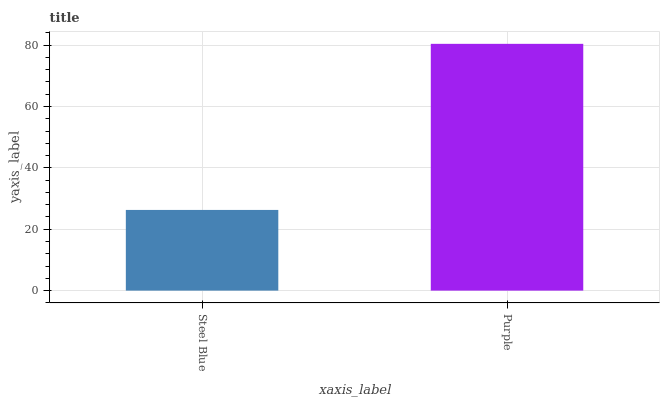Is Steel Blue the minimum?
Answer yes or no. Yes. Is Purple the maximum?
Answer yes or no. Yes. Is Purple the minimum?
Answer yes or no. No. Is Purple greater than Steel Blue?
Answer yes or no. Yes. Is Steel Blue less than Purple?
Answer yes or no. Yes. Is Steel Blue greater than Purple?
Answer yes or no. No. Is Purple less than Steel Blue?
Answer yes or no. No. Is Purple the high median?
Answer yes or no. Yes. Is Steel Blue the low median?
Answer yes or no. Yes. Is Steel Blue the high median?
Answer yes or no. No. Is Purple the low median?
Answer yes or no. No. 